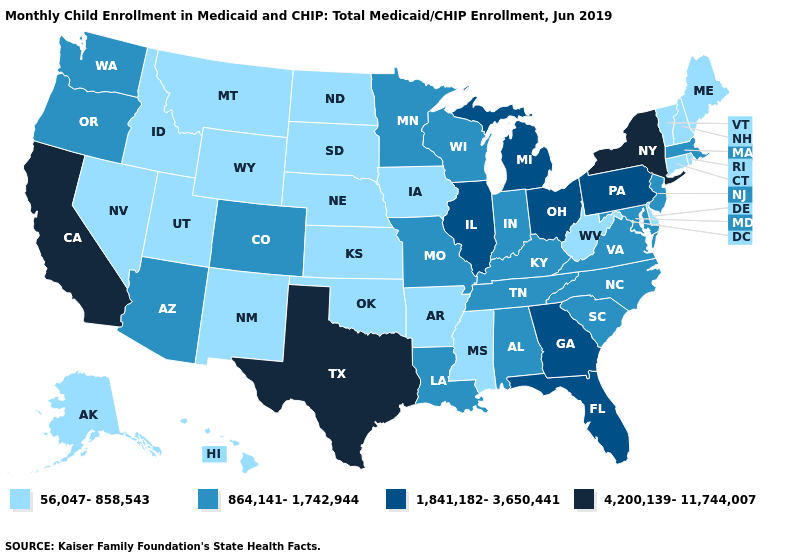Name the states that have a value in the range 1,841,182-3,650,441?
Answer briefly. Florida, Georgia, Illinois, Michigan, Ohio, Pennsylvania. What is the value of Michigan?
Quick response, please. 1,841,182-3,650,441. Name the states that have a value in the range 4,200,139-11,744,007?
Short answer required. California, New York, Texas. What is the lowest value in the MidWest?
Be succinct. 56,047-858,543. Does the map have missing data?
Quick response, please. No. Does the map have missing data?
Short answer required. No. Name the states that have a value in the range 864,141-1,742,944?
Give a very brief answer. Alabama, Arizona, Colorado, Indiana, Kentucky, Louisiana, Maryland, Massachusetts, Minnesota, Missouri, New Jersey, North Carolina, Oregon, South Carolina, Tennessee, Virginia, Washington, Wisconsin. What is the highest value in the MidWest ?
Keep it brief. 1,841,182-3,650,441. Does New York have the highest value in the USA?
Be succinct. Yes. What is the value of North Carolina?
Concise answer only. 864,141-1,742,944. Among the states that border Tennessee , does Missouri have the lowest value?
Write a very short answer. No. Name the states that have a value in the range 1,841,182-3,650,441?
Give a very brief answer. Florida, Georgia, Illinois, Michigan, Ohio, Pennsylvania. What is the value of New Hampshire?
Concise answer only. 56,047-858,543. Among the states that border Pennsylvania , does New York have the lowest value?
Be succinct. No. Does Utah have the highest value in the West?
Keep it brief. No. 